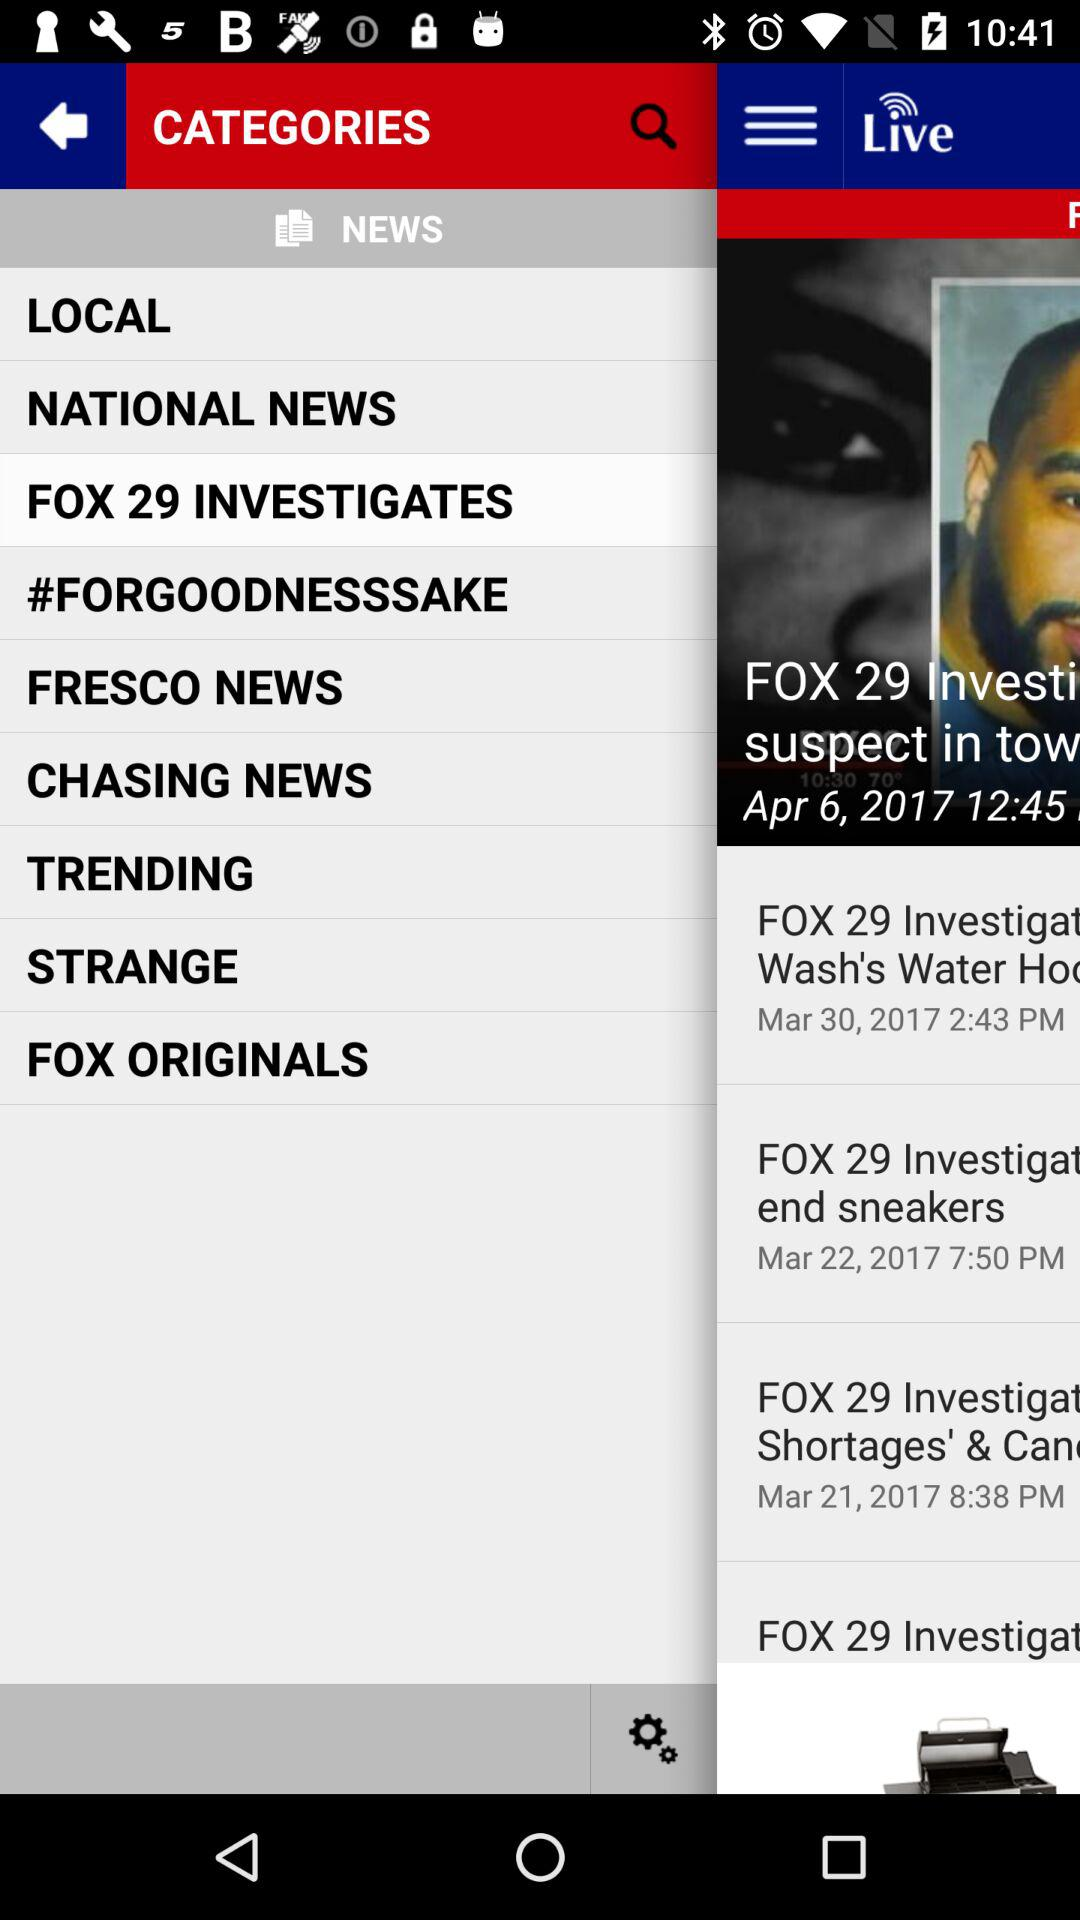What are the available categories? The available categories are "LOCAL", "NATIONAL NEWS", "FOX 29 INVESTIGATES", "#FORGOODNESSSAKE", "FRESCO NEWS", "CHASING NEWS", "TRENDING", "STRANGE", and "FOX ORIGINALS". 